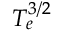Convert formula to latex. <formula><loc_0><loc_0><loc_500><loc_500>T _ { e } ^ { 3 / 2 }</formula> 